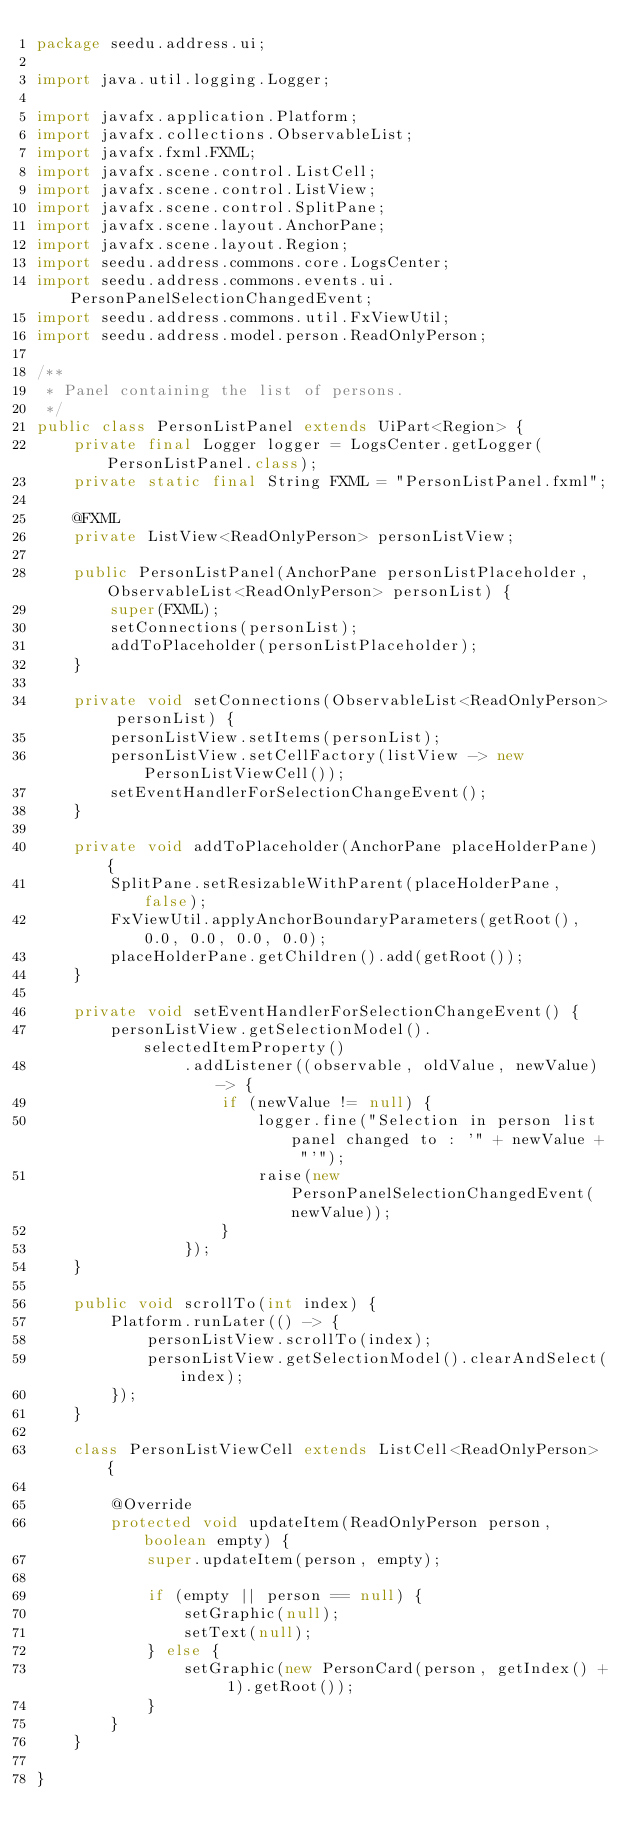Convert code to text. <code><loc_0><loc_0><loc_500><loc_500><_Java_>package seedu.address.ui;

import java.util.logging.Logger;

import javafx.application.Platform;
import javafx.collections.ObservableList;
import javafx.fxml.FXML;
import javafx.scene.control.ListCell;
import javafx.scene.control.ListView;
import javafx.scene.control.SplitPane;
import javafx.scene.layout.AnchorPane;
import javafx.scene.layout.Region;
import seedu.address.commons.core.LogsCenter;
import seedu.address.commons.events.ui.PersonPanelSelectionChangedEvent;
import seedu.address.commons.util.FxViewUtil;
import seedu.address.model.person.ReadOnlyPerson;

/**
 * Panel containing the list of persons.
 */
public class PersonListPanel extends UiPart<Region> {
    private final Logger logger = LogsCenter.getLogger(PersonListPanel.class);
    private static final String FXML = "PersonListPanel.fxml";

    @FXML
    private ListView<ReadOnlyPerson> personListView;

    public PersonListPanel(AnchorPane personListPlaceholder, ObservableList<ReadOnlyPerson> personList) {
        super(FXML);
        setConnections(personList);
        addToPlaceholder(personListPlaceholder);
    }

    private void setConnections(ObservableList<ReadOnlyPerson> personList) {
        personListView.setItems(personList);
        personListView.setCellFactory(listView -> new PersonListViewCell());
        setEventHandlerForSelectionChangeEvent();
    }

    private void addToPlaceholder(AnchorPane placeHolderPane) {
        SplitPane.setResizableWithParent(placeHolderPane, false);
        FxViewUtil.applyAnchorBoundaryParameters(getRoot(), 0.0, 0.0, 0.0, 0.0);
        placeHolderPane.getChildren().add(getRoot());
    }

    private void setEventHandlerForSelectionChangeEvent() {
        personListView.getSelectionModel().selectedItemProperty()
                .addListener((observable, oldValue, newValue) -> {
                    if (newValue != null) {
                        logger.fine("Selection in person list panel changed to : '" + newValue + "'");
                        raise(new PersonPanelSelectionChangedEvent(newValue));
                    }
                });
    }

    public void scrollTo(int index) {
        Platform.runLater(() -> {
            personListView.scrollTo(index);
            personListView.getSelectionModel().clearAndSelect(index);
        });
    }

    class PersonListViewCell extends ListCell<ReadOnlyPerson> {

        @Override
        protected void updateItem(ReadOnlyPerson person, boolean empty) {
            super.updateItem(person, empty);

            if (empty || person == null) {
                setGraphic(null);
                setText(null);
            } else {
                setGraphic(new PersonCard(person, getIndex() + 1).getRoot());
            }
        }
    }

}
</code> 